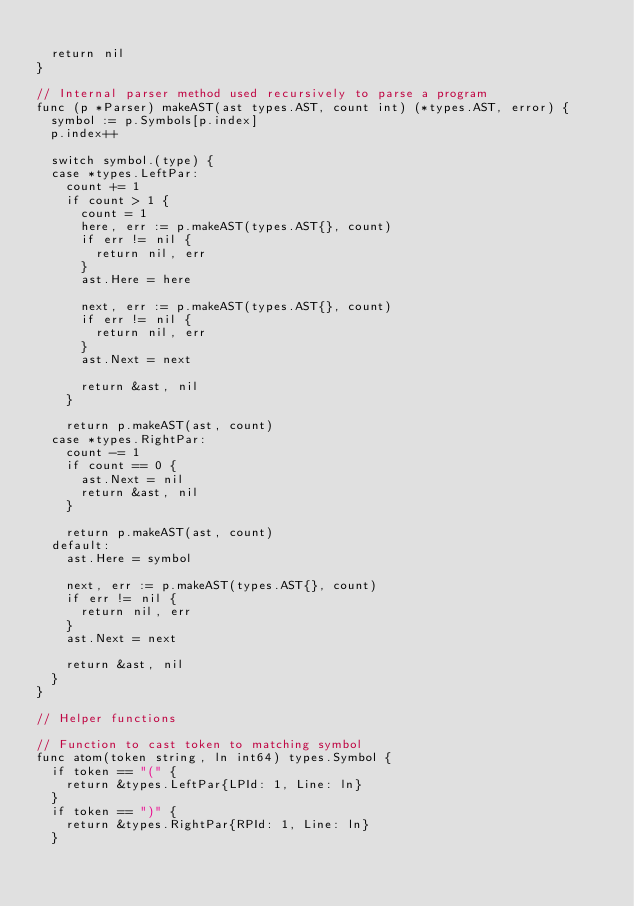<code> <loc_0><loc_0><loc_500><loc_500><_Go_>
	return nil
}

// Internal parser method used recursively to parse a program
func (p *Parser) makeAST(ast types.AST, count int) (*types.AST, error) {
	symbol := p.Symbols[p.index]
	p.index++

	switch symbol.(type) {
	case *types.LeftPar:
		count += 1
		if count > 1 {
			count = 1
			here, err := p.makeAST(types.AST{}, count)
			if err != nil {
				return nil, err
			}
			ast.Here = here

			next, err := p.makeAST(types.AST{}, count)
			if err != nil {
				return nil, err
			}
			ast.Next = next

			return &ast, nil
		}

		return p.makeAST(ast, count)
	case *types.RightPar:
		count -= 1
		if count == 0 {
			ast.Next = nil
			return &ast, nil
		}

		return p.makeAST(ast, count)
	default:
		ast.Here = symbol

		next, err := p.makeAST(types.AST{}, count)
		if err != nil {
			return nil, err
		}
		ast.Next = next

		return &ast, nil
	}
}

// Helper functions

// Function to cast token to matching symbol
func atom(token string, ln int64) types.Symbol {
	if token == "(" {
		return &types.LeftPar{LPId: 1, Line: ln}
	}
	if token == ")" {
		return &types.RightPar{RPId: 1, Line: ln}
	}</code> 